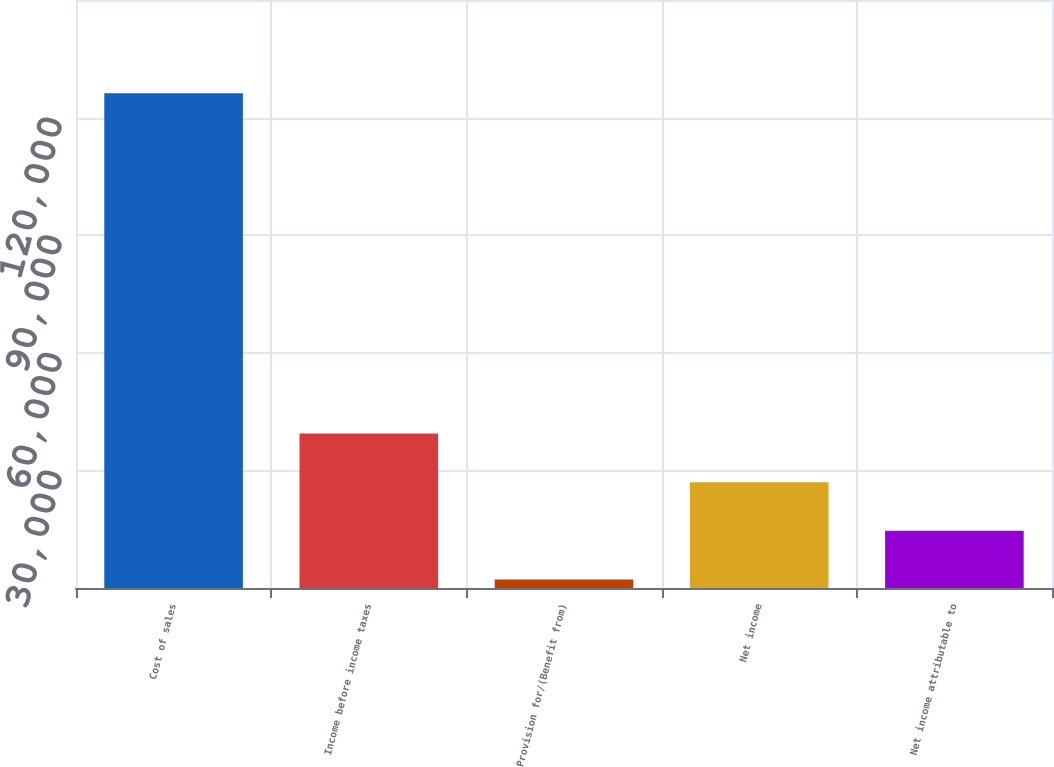<chart> <loc_0><loc_0><loc_500><loc_500><bar_chart><fcel>Cost of sales<fcel>Income before income taxes<fcel>Provision for/(Benefit from)<fcel>Net income<fcel>Net income attributable to<nl><fcel>126195<fcel>39387.3<fcel>2184<fcel>26986.2<fcel>14585.1<nl></chart> 